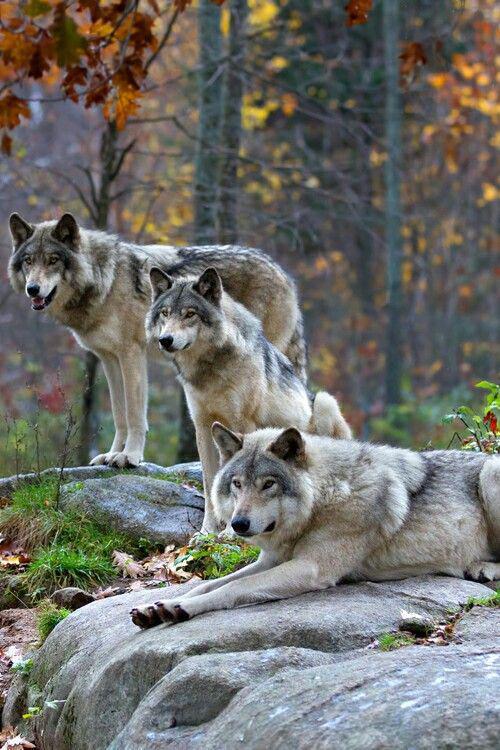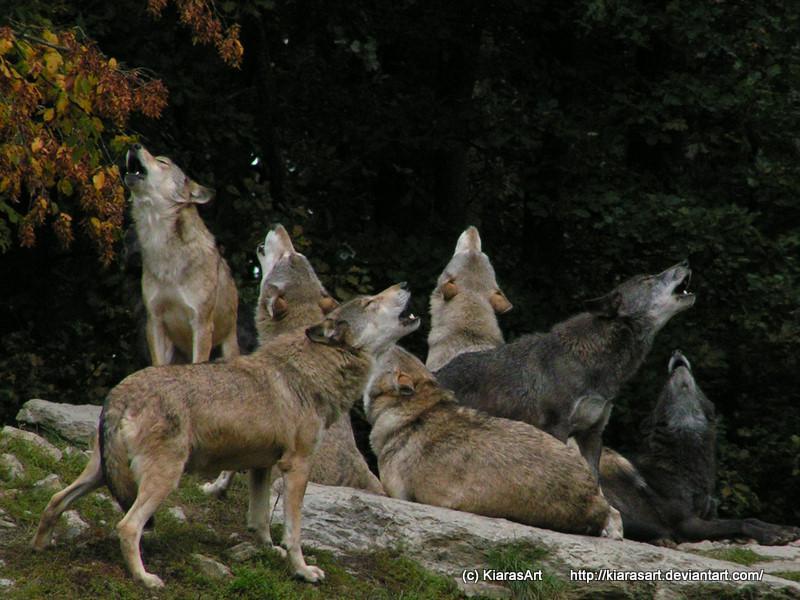The first image is the image on the left, the second image is the image on the right. Given the left and right images, does the statement "The right image features an adult wolf with left-turned face next to multiple pups." hold true? Answer yes or no. No. The first image is the image on the left, the second image is the image on the right. Given the left and right images, does the statement "There is a single wolf with its face partially covered by foliage in one of the images." hold true? Answer yes or no. No. 